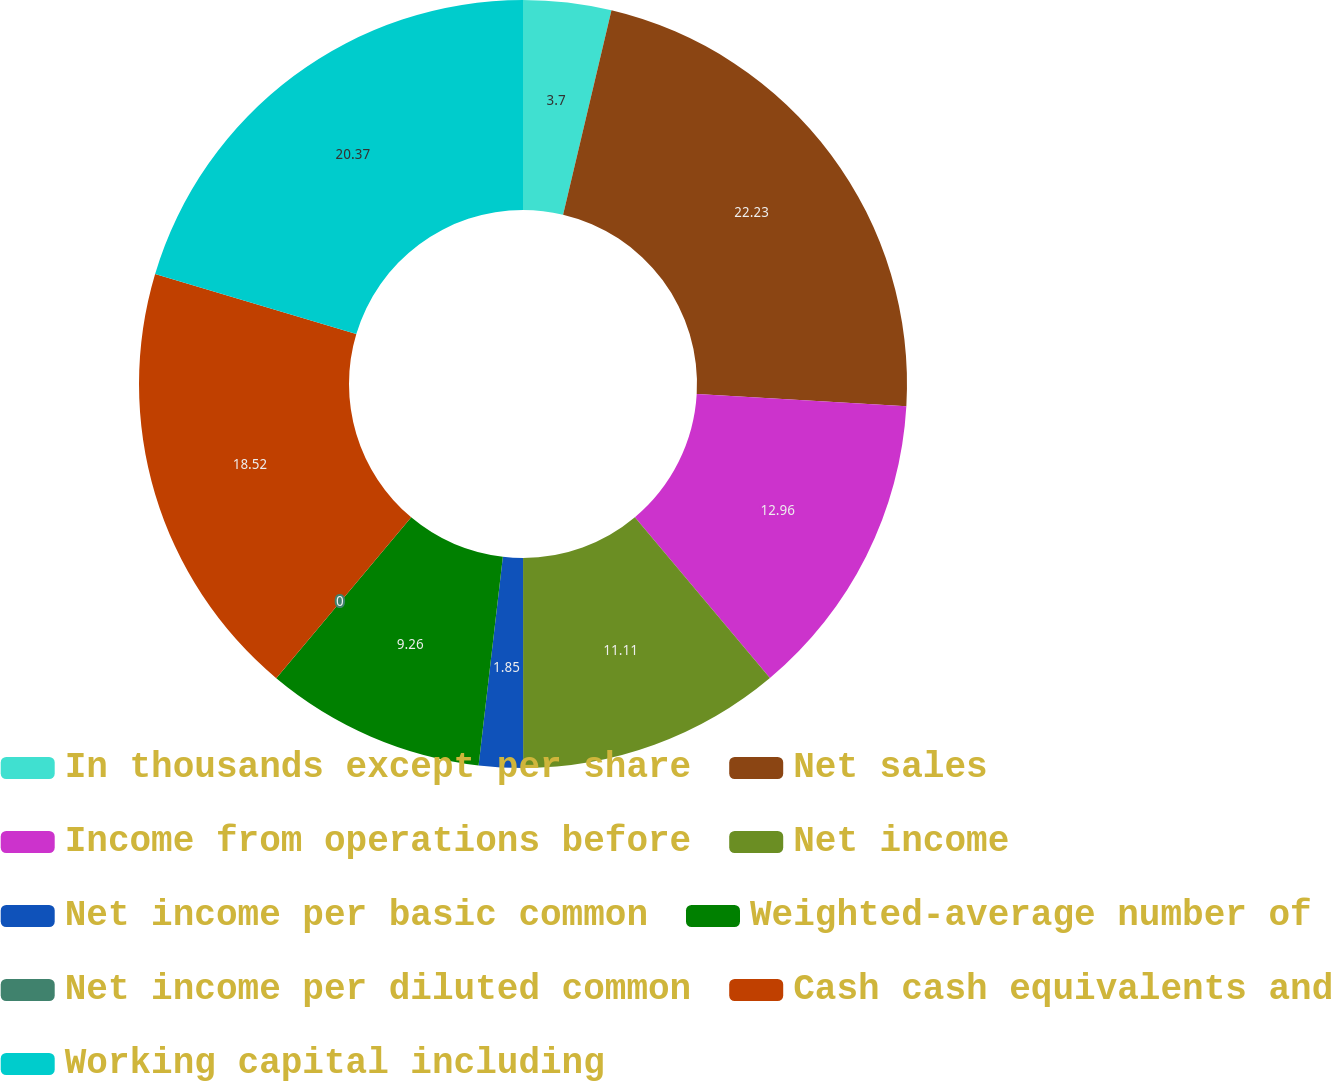Convert chart to OTSL. <chart><loc_0><loc_0><loc_500><loc_500><pie_chart><fcel>In thousands except per share<fcel>Net sales<fcel>Income from operations before<fcel>Net income<fcel>Net income per basic common<fcel>Weighted-average number of<fcel>Net income per diluted common<fcel>Cash cash equivalents and<fcel>Working capital including<nl><fcel>3.7%<fcel>22.22%<fcel>12.96%<fcel>11.11%<fcel>1.85%<fcel>9.26%<fcel>0.0%<fcel>18.52%<fcel>20.37%<nl></chart> 